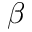Convert formula to latex. <formula><loc_0><loc_0><loc_500><loc_500>\beta</formula> 